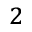<formula> <loc_0><loc_0><loc_500><loc_500>^ { 2 }</formula> 